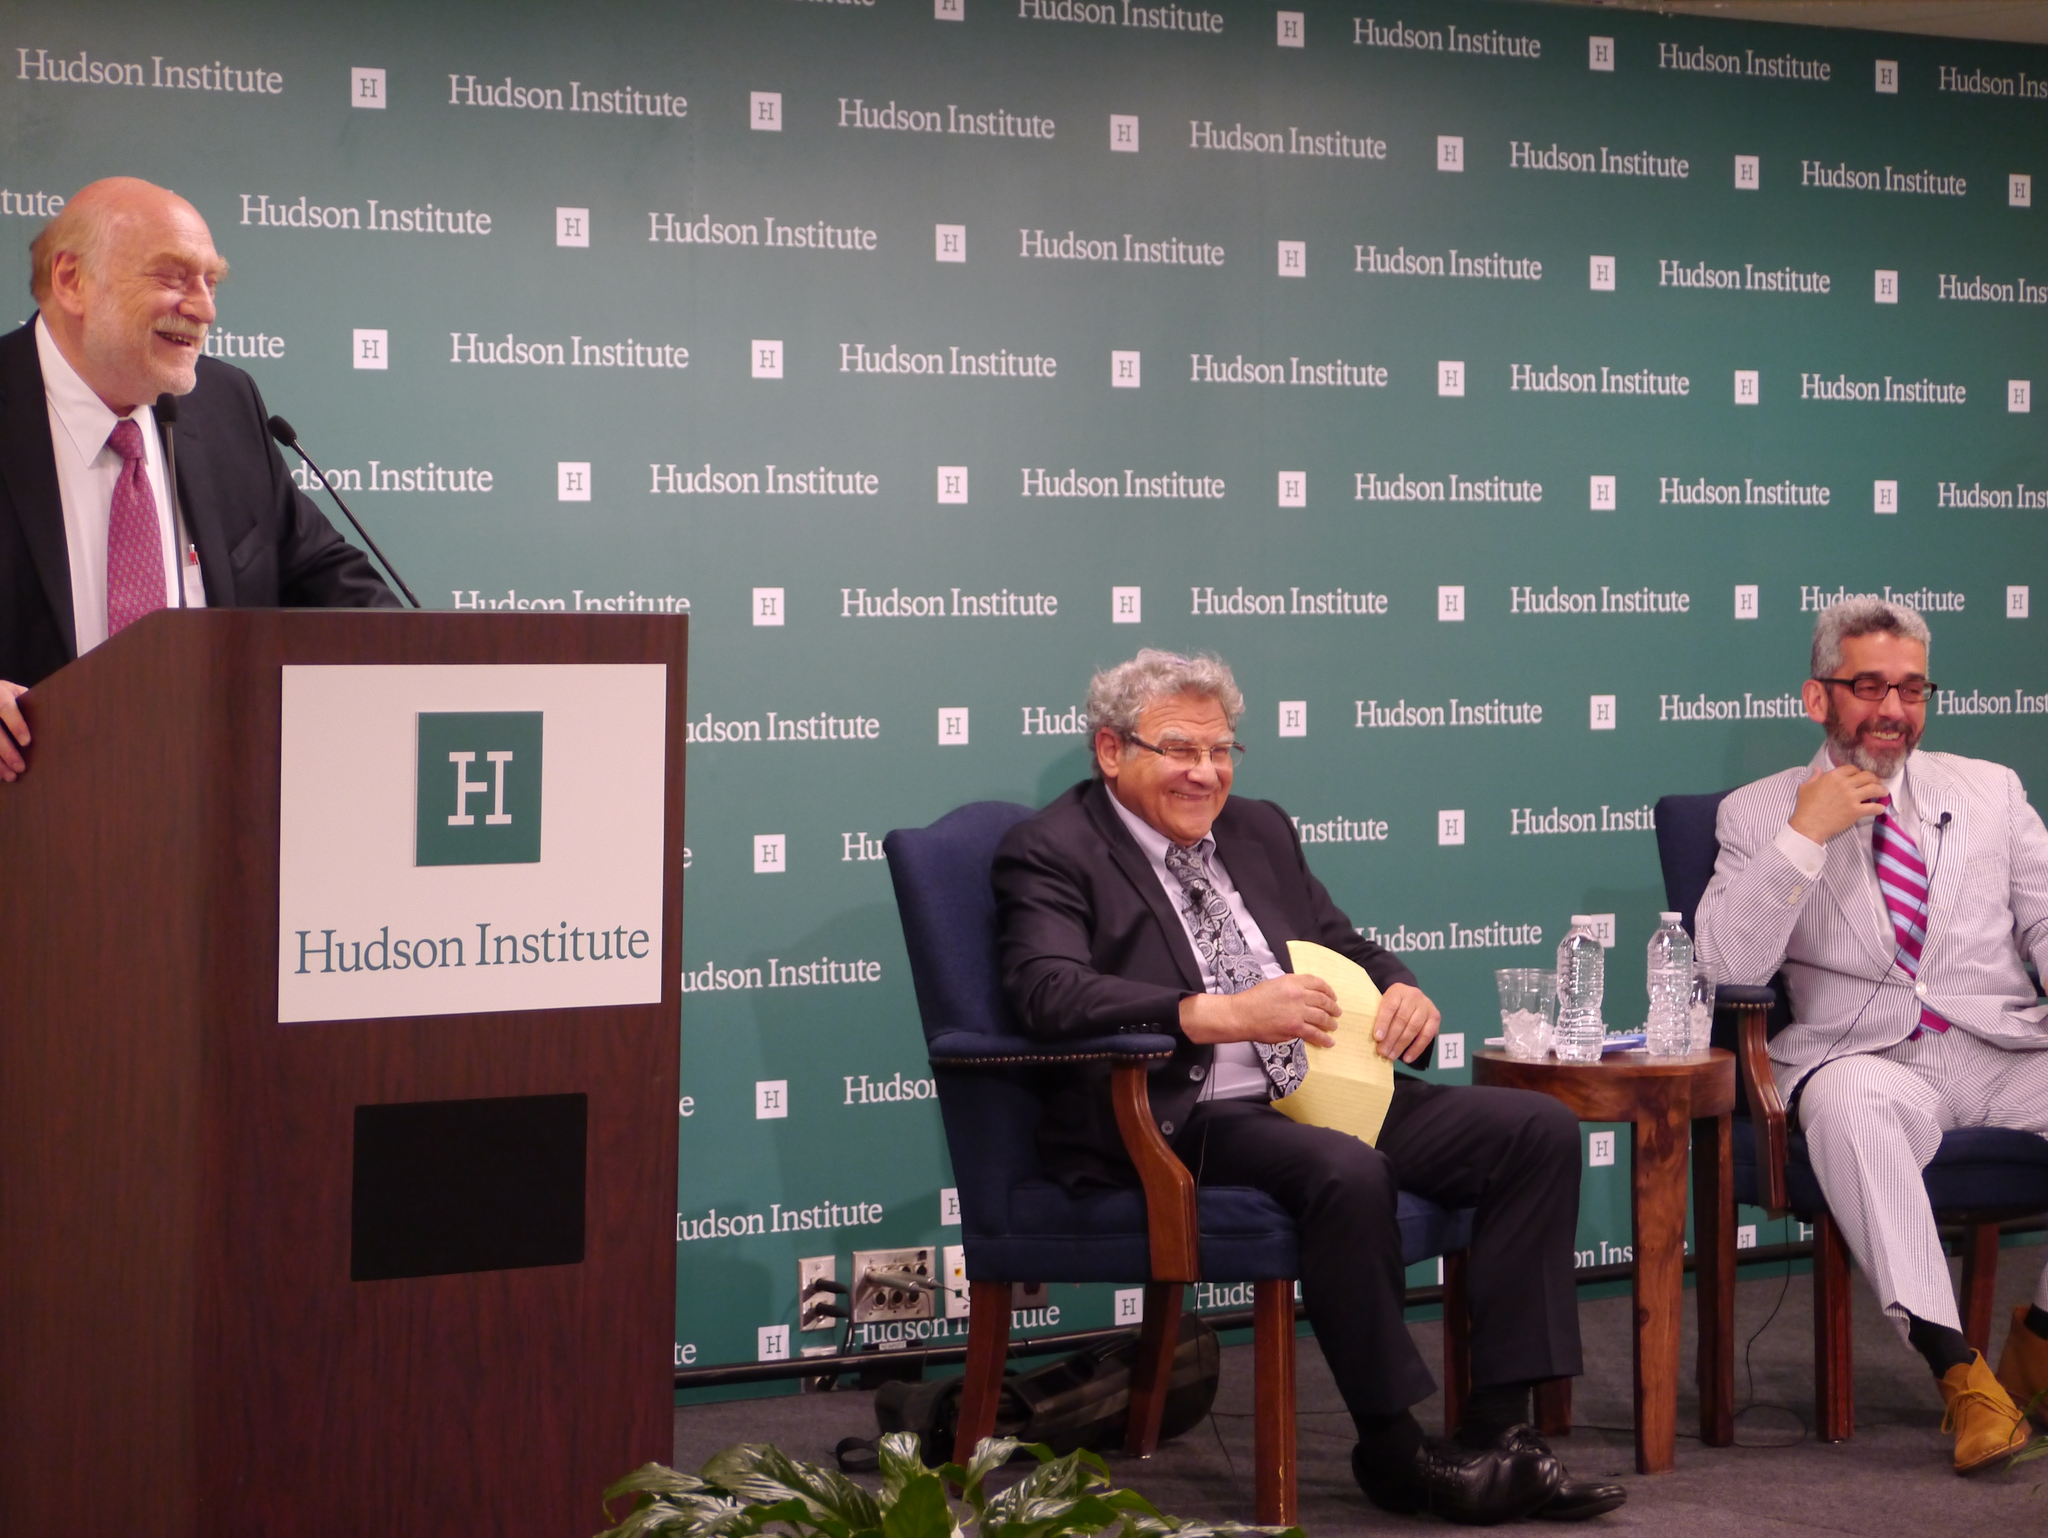Can you describe this image briefly? In this image we can see people, podium, chairs, bottles, table, plant and in the background we can see a banner with some text. 